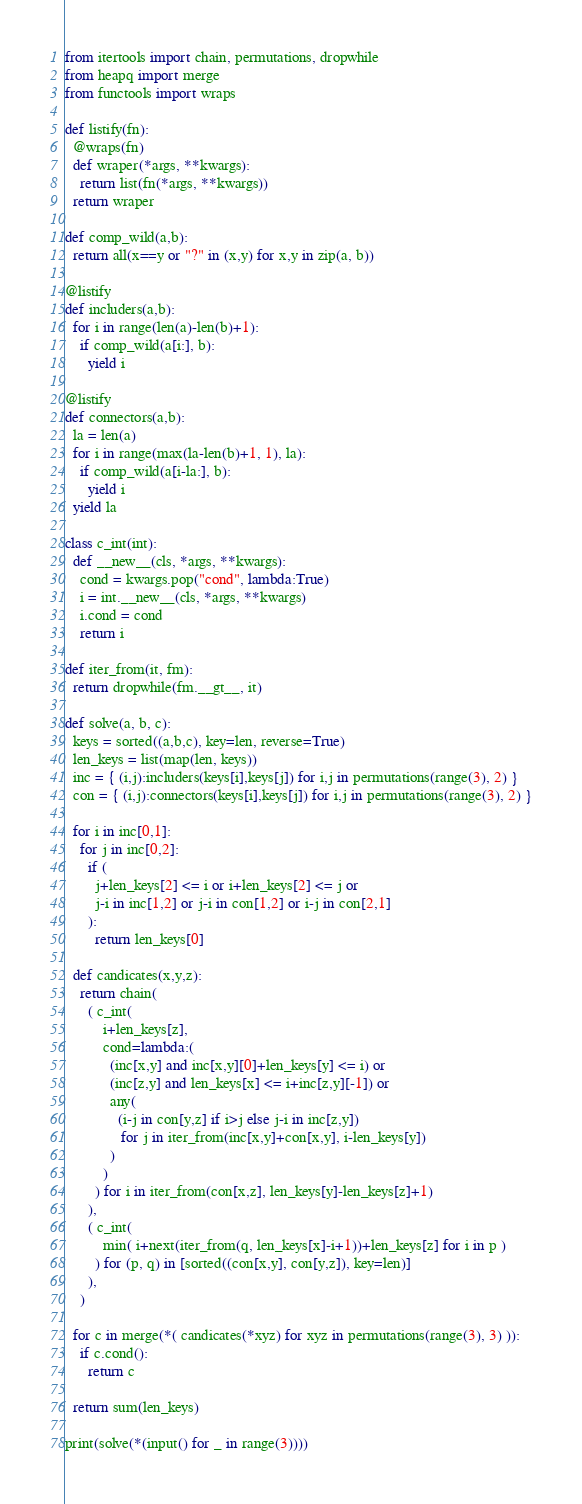<code> <loc_0><loc_0><loc_500><loc_500><_Python_>from itertools import chain, permutations, dropwhile
from heapq import merge
from functools import wraps

def listify(fn):
  @wraps(fn)
  def wraper(*args, **kwargs):
    return list(fn(*args, **kwargs))
  return wraper

def comp_wild(a,b):
  return all(x==y or "?" in (x,y) for x,y in zip(a, b))

@listify
def includers(a,b):
  for i in range(len(a)-len(b)+1):
    if comp_wild(a[i:], b):
      yield i

@listify
def connectors(a,b):
  la = len(a)
  for i in range(max(la-len(b)+1, 1), la):
    if comp_wild(a[i-la:], b):
      yield i
  yield la

class c_int(int):
  def __new__(cls, *args, **kwargs):
    cond = kwargs.pop("cond", lambda:True)
    i = int.__new__(cls, *args, **kwargs)
    i.cond = cond
    return i

def iter_from(it, fm):
  return dropwhile(fm.__gt__, it)

def solve(a, b, c):
  keys = sorted((a,b,c), key=len, reverse=True)
  len_keys = list(map(len, keys))
  inc = { (i,j):includers(keys[i],keys[j]) for i,j in permutations(range(3), 2) }
  con = { (i,j):connectors(keys[i],keys[j]) for i,j in permutations(range(3), 2) }
  
  for i in inc[0,1]:
    for j in inc[0,2]:
      if (
        j+len_keys[2] <= i or i+len_keys[2] <= j or
        j-i in inc[1,2] or j-i in con[1,2] or i-j in con[2,1]
      ):
        return len_keys[0]
  
  def candicates(x,y,z):
    return chain(
      ( c_int(
          i+len_keys[z], 
          cond=lambda:(
            (inc[x,y] and inc[x,y][0]+len_keys[y] <= i) or 
            (inc[z,y] and len_keys[x] <= i+inc[z,y][-1]) or 
            any(
              (i-j in con[y,z] if i>j else j-i in inc[z,y])
               for j in iter_from(inc[x,y]+con[x,y], i-len_keys[y])
            )
          )
        ) for i in iter_from(con[x,z], len_keys[y]-len_keys[z]+1)
      ),
      ( c_int(
          min( i+next(iter_from(q, len_keys[x]-i+1))+len_keys[z] for i in p )
        ) for (p, q) in [sorted((con[x,y], con[y,z]), key=len)]
      ),
    )
  
  for c in merge(*( candicates(*xyz) for xyz in permutations(range(3), 3) )):
    if c.cond():
      return c
  
  return sum(len_keys)

print(solve(*(input() for _ in range(3))))
</code> 